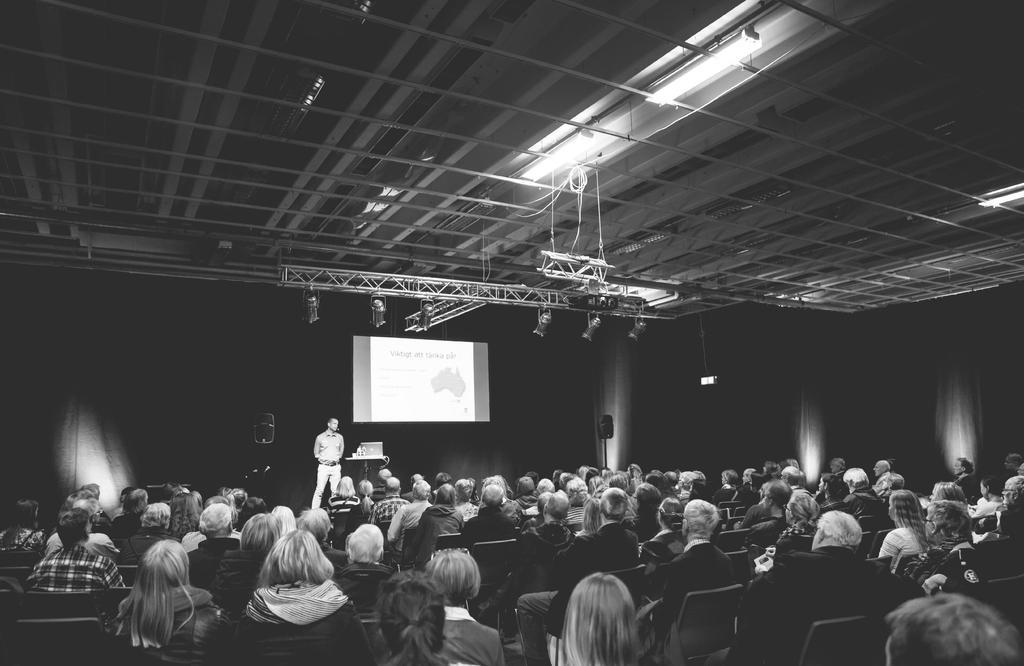Can you describe this image briefly? In this image in a big hall there are many people sitting on chairs. On the stage a person is standing behind him there is a screen. This is a table. This is a speaker. At the top there are lights. This is the roof. 